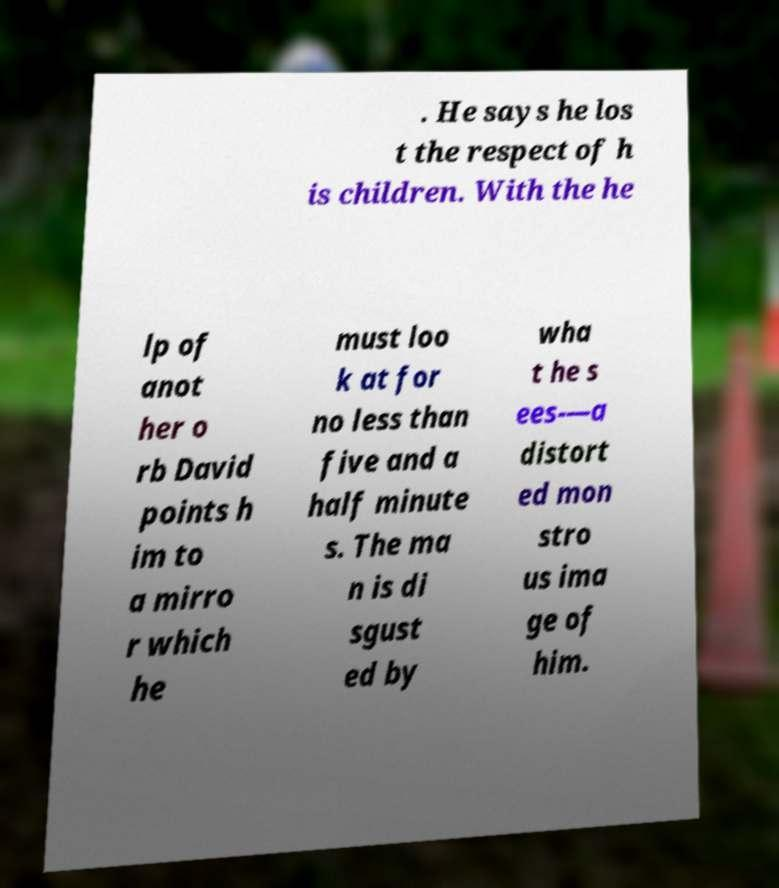There's text embedded in this image that I need extracted. Can you transcribe it verbatim? . He says he los t the respect of h is children. With the he lp of anot her o rb David points h im to a mirro r which he must loo k at for no less than five and a half minute s. The ma n is di sgust ed by wha t he s ees-—a distort ed mon stro us ima ge of him. 